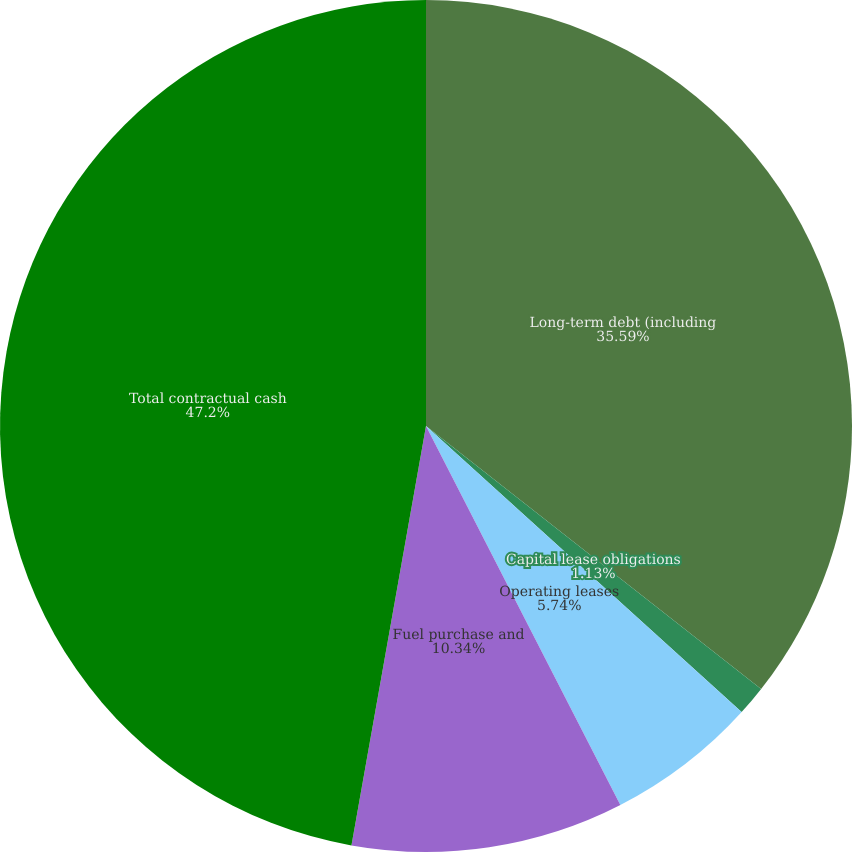Convert chart to OTSL. <chart><loc_0><loc_0><loc_500><loc_500><pie_chart><fcel>Long-term debt (including<fcel>Capital lease obligations<fcel>Operating leases<fcel>Fuel purchase and<fcel>Total contractual cash<nl><fcel>35.59%<fcel>1.13%<fcel>5.74%<fcel>10.34%<fcel>47.2%<nl></chart> 